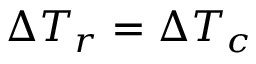Convert formula to latex. <formula><loc_0><loc_0><loc_500><loc_500>\Delta T _ { r } = \Delta T _ { c }</formula> 